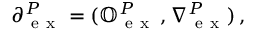Convert formula to latex. <formula><loc_0><loc_0><loc_500><loc_500>\partial _ { e x } ^ { P } = ( \mathbb { O } _ { e x } ^ { P } \, , _ { e x } ^ { P } ) \, ,</formula> 